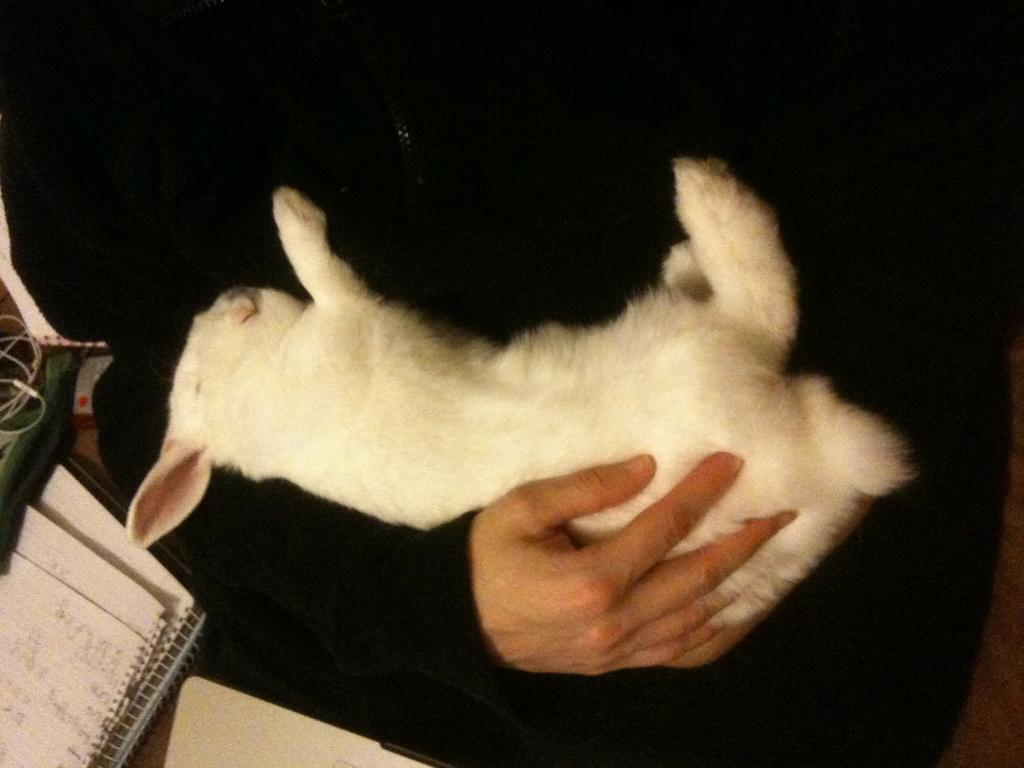What is the main subject of the image? There is a person in the image. What is the person holding in the image? The person is holding an animal. What else can be seen in the image besides the person and the animal? There are books, a bag, and a headset in the image. Can you describe the unspecified objects at the bottom of the image? Unfortunately, the facts provided do not specify the nature of the objects at the bottom of the image. How many parcels are being delivered by the animal in the image? There is no mention of parcels or delivery in the image. The person is holding an animal, but its purpose or activity is not specified. 